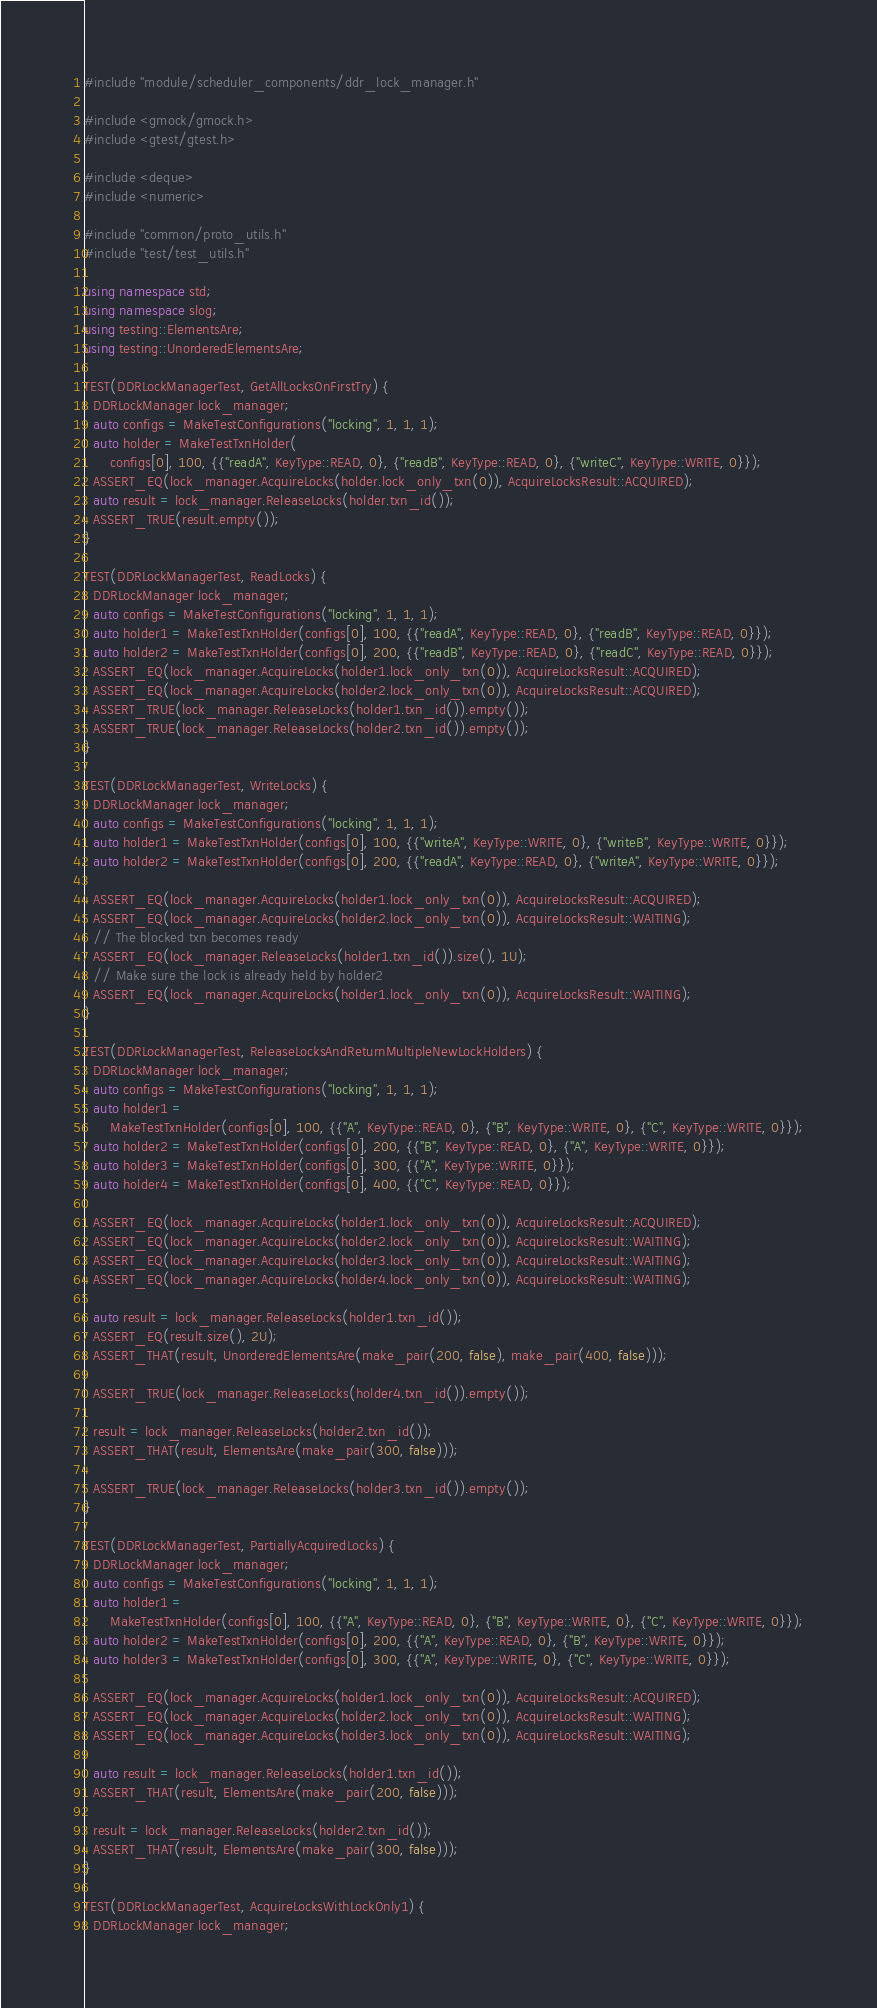Convert code to text. <code><loc_0><loc_0><loc_500><loc_500><_C++_>#include "module/scheduler_components/ddr_lock_manager.h"

#include <gmock/gmock.h>
#include <gtest/gtest.h>

#include <deque>
#include <numeric>

#include "common/proto_utils.h"
#include "test/test_utils.h"

using namespace std;
using namespace slog;
using testing::ElementsAre;
using testing::UnorderedElementsAre;

TEST(DDRLockManagerTest, GetAllLocksOnFirstTry) {
  DDRLockManager lock_manager;
  auto configs = MakeTestConfigurations("locking", 1, 1, 1);
  auto holder = MakeTestTxnHolder(
      configs[0], 100, {{"readA", KeyType::READ, 0}, {"readB", KeyType::READ, 0}, {"writeC", KeyType::WRITE, 0}});
  ASSERT_EQ(lock_manager.AcquireLocks(holder.lock_only_txn(0)), AcquireLocksResult::ACQUIRED);
  auto result = lock_manager.ReleaseLocks(holder.txn_id());
  ASSERT_TRUE(result.empty());
}

TEST(DDRLockManagerTest, ReadLocks) {
  DDRLockManager lock_manager;
  auto configs = MakeTestConfigurations("locking", 1, 1, 1);
  auto holder1 = MakeTestTxnHolder(configs[0], 100, {{"readA", KeyType::READ, 0}, {"readB", KeyType::READ, 0}});
  auto holder2 = MakeTestTxnHolder(configs[0], 200, {{"readB", KeyType::READ, 0}, {"readC", KeyType::READ, 0}});
  ASSERT_EQ(lock_manager.AcquireLocks(holder1.lock_only_txn(0)), AcquireLocksResult::ACQUIRED);
  ASSERT_EQ(lock_manager.AcquireLocks(holder2.lock_only_txn(0)), AcquireLocksResult::ACQUIRED);
  ASSERT_TRUE(lock_manager.ReleaseLocks(holder1.txn_id()).empty());
  ASSERT_TRUE(lock_manager.ReleaseLocks(holder2.txn_id()).empty());
}

TEST(DDRLockManagerTest, WriteLocks) {
  DDRLockManager lock_manager;
  auto configs = MakeTestConfigurations("locking", 1, 1, 1);
  auto holder1 = MakeTestTxnHolder(configs[0], 100, {{"writeA", KeyType::WRITE, 0}, {"writeB", KeyType::WRITE, 0}});
  auto holder2 = MakeTestTxnHolder(configs[0], 200, {{"readA", KeyType::READ, 0}, {"writeA", KeyType::WRITE, 0}});

  ASSERT_EQ(lock_manager.AcquireLocks(holder1.lock_only_txn(0)), AcquireLocksResult::ACQUIRED);
  ASSERT_EQ(lock_manager.AcquireLocks(holder2.lock_only_txn(0)), AcquireLocksResult::WAITING);
  // The blocked txn becomes ready
  ASSERT_EQ(lock_manager.ReleaseLocks(holder1.txn_id()).size(), 1U);
  // Make sure the lock is already held by holder2
  ASSERT_EQ(lock_manager.AcquireLocks(holder1.lock_only_txn(0)), AcquireLocksResult::WAITING);
}

TEST(DDRLockManagerTest, ReleaseLocksAndReturnMultipleNewLockHolders) {
  DDRLockManager lock_manager;
  auto configs = MakeTestConfigurations("locking", 1, 1, 1);
  auto holder1 =
      MakeTestTxnHolder(configs[0], 100, {{"A", KeyType::READ, 0}, {"B", KeyType::WRITE, 0}, {"C", KeyType::WRITE, 0}});
  auto holder2 = MakeTestTxnHolder(configs[0], 200, {{"B", KeyType::READ, 0}, {"A", KeyType::WRITE, 0}});
  auto holder3 = MakeTestTxnHolder(configs[0], 300, {{"A", KeyType::WRITE, 0}});
  auto holder4 = MakeTestTxnHolder(configs[0], 400, {{"C", KeyType::READ, 0}});

  ASSERT_EQ(lock_manager.AcquireLocks(holder1.lock_only_txn(0)), AcquireLocksResult::ACQUIRED);
  ASSERT_EQ(lock_manager.AcquireLocks(holder2.lock_only_txn(0)), AcquireLocksResult::WAITING);
  ASSERT_EQ(lock_manager.AcquireLocks(holder3.lock_only_txn(0)), AcquireLocksResult::WAITING);
  ASSERT_EQ(lock_manager.AcquireLocks(holder4.lock_only_txn(0)), AcquireLocksResult::WAITING);

  auto result = lock_manager.ReleaseLocks(holder1.txn_id());
  ASSERT_EQ(result.size(), 2U);
  ASSERT_THAT(result, UnorderedElementsAre(make_pair(200, false), make_pair(400, false)));

  ASSERT_TRUE(lock_manager.ReleaseLocks(holder4.txn_id()).empty());

  result = lock_manager.ReleaseLocks(holder2.txn_id());
  ASSERT_THAT(result, ElementsAre(make_pair(300, false)));

  ASSERT_TRUE(lock_manager.ReleaseLocks(holder3.txn_id()).empty());
}

TEST(DDRLockManagerTest, PartiallyAcquiredLocks) {
  DDRLockManager lock_manager;
  auto configs = MakeTestConfigurations("locking", 1, 1, 1);
  auto holder1 =
      MakeTestTxnHolder(configs[0], 100, {{"A", KeyType::READ, 0}, {"B", KeyType::WRITE, 0}, {"C", KeyType::WRITE, 0}});
  auto holder2 = MakeTestTxnHolder(configs[0], 200, {{"A", KeyType::READ, 0}, {"B", KeyType::WRITE, 0}});
  auto holder3 = MakeTestTxnHolder(configs[0], 300, {{"A", KeyType::WRITE, 0}, {"C", KeyType::WRITE, 0}});

  ASSERT_EQ(lock_manager.AcquireLocks(holder1.lock_only_txn(0)), AcquireLocksResult::ACQUIRED);
  ASSERT_EQ(lock_manager.AcquireLocks(holder2.lock_only_txn(0)), AcquireLocksResult::WAITING);
  ASSERT_EQ(lock_manager.AcquireLocks(holder3.lock_only_txn(0)), AcquireLocksResult::WAITING);

  auto result = lock_manager.ReleaseLocks(holder1.txn_id());
  ASSERT_THAT(result, ElementsAre(make_pair(200, false)));

  result = lock_manager.ReleaseLocks(holder2.txn_id());
  ASSERT_THAT(result, ElementsAre(make_pair(300, false)));
}

TEST(DDRLockManagerTest, AcquireLocksWithLockOnly1) {
  DDRLockManager lock_manager;</code> 